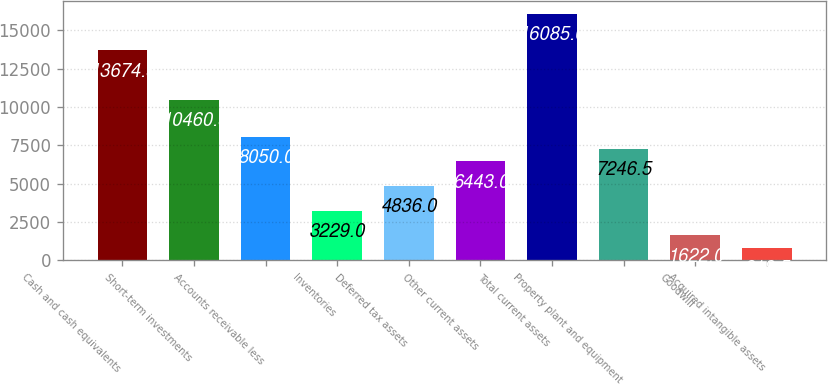<chart> <loc_0><loc_0><loc_500><loc_500><bar_chart><fcel>Cash and cash equivalents<fcel>Short-term investments<fcel>Accounts receivable less<fcel>Inventories<fcel>Deferred tax assets<fcel>Other current assets<fcel>Total current assets<fcel>Property plant and equipment<fcel>Goodwill<fcel>Acquired intangible assets<nl><fcel>13674.5<fcel>10460.5<fcel>8050<fcel>3229<fcel>4836<fcel>6443<fcel>16085<fcel>7246.5<fcel>1622<fcel>818.5<nl></chart> 